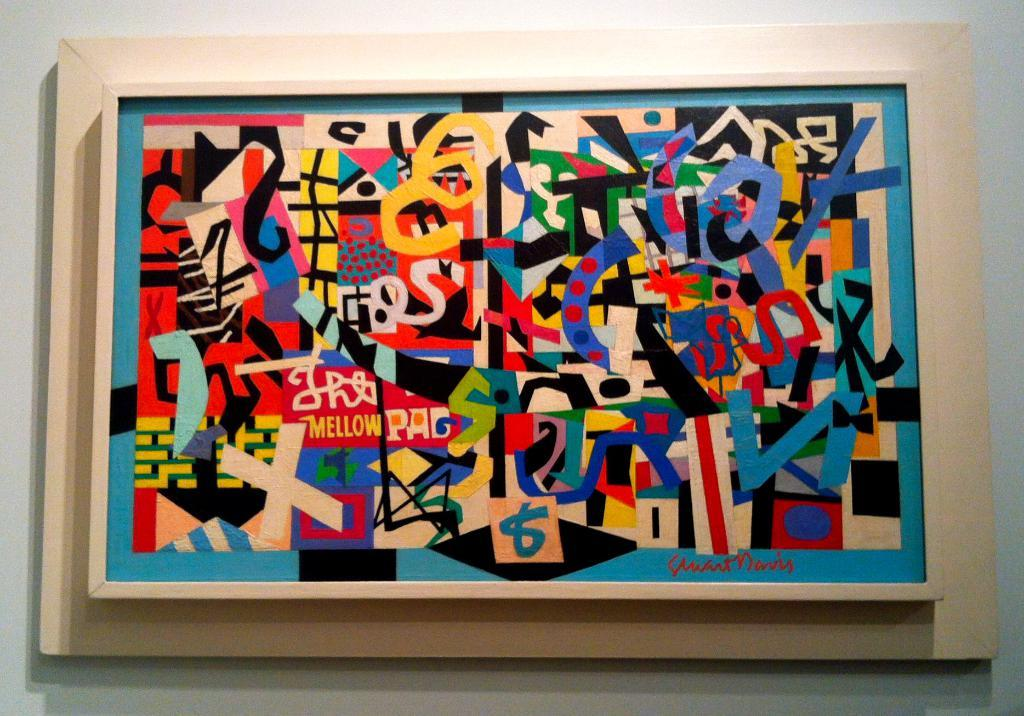<image>
Give a short and clear explanation of the subsequent image. a picture in an art gallery that says 'mellow' on it 